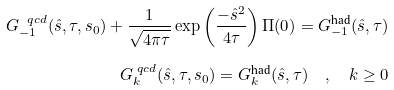<formula> <loc_0><loc_0><loc_500><loc_500>G _ { - 1 } ^ { \ q c d } ( \hat { s } , \tau , s _ { 0 } ) + \frac { 1 } { \sqrt { 4 \pi \tau } } \exp \left ( \frac { - \hat { s } ^ { 2 } } { 4 \tau } \right ) \Pi ( 0 ) = G _ { - 1 } ^ { \text {had} } ( \hat { s } , \tau ) \\ G _ { k } ^ { \ q c d } ( \hat { s } , \tau , s _ { 0 } ) = G _ { k } ^ { \text {had} } ( \hat { s } , \tau ) \quad , \quad k \geq 0</formula> 